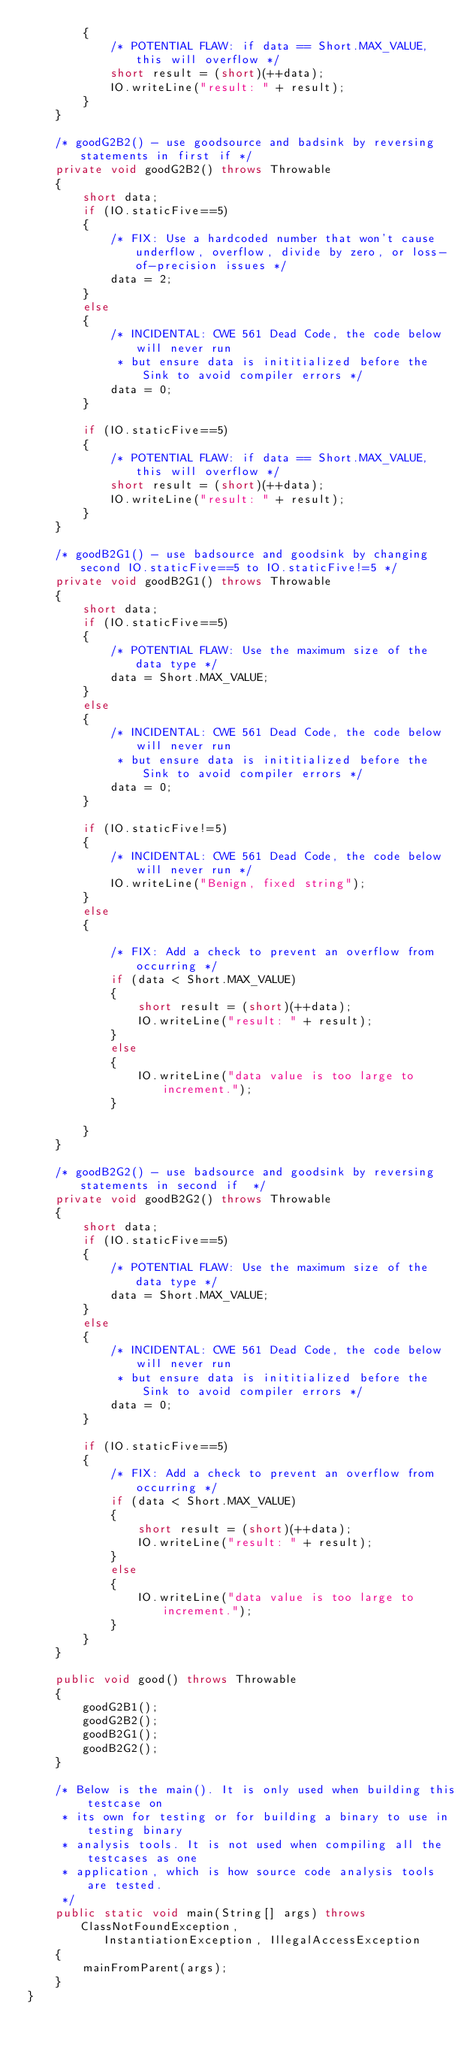<code> <loc_0><loc_0><loc_500><loc_500><_Java_>        {
            /* POTENTIAL FLAW: if data == Short.MAX_VALUE, this will overflow */
            short result = (short)(++data);
            IO.writeLine("result: " + result);
        }
    }

    /* goodG2B2() - use goodsource and badsink by reversing statements in first if */
    private void goodG2B2() throws Throwable
    {
        short data;
        if (IO.staticFive==5)
        {
            /* FIX: Use a hardcoded number that won't cause underflow, overflow, divide by zero, or loss-of-precision issues */
            data = 2;
        }
        else
        {
            /* INCIDENTAL: CWE 561 Dead Code, the code below will never run
             * but ensure data is inititialized before the Sink to avoid compiler errors */
            data = 0;
        }

        if (IO.staticFive==5)
        {
            /* POTENTIAL FLAW: if data == Short.MAX_VALUE, this will overflow */
            short result = (short)(++data);
            IO.writeLine("result: " + result);
        }
    }

    /* goodB2G1() - use badsource and goodsink by changing second IO.staticFive==5 to IO.staticFive!=5 */
    private void goodB2G1() throws Throwable
    {
        short data;
        if (IO.staticFive==5)
        {
            /* POTENTIAL FLAW: Use the maximum size of the data type */
            data = Short.MAX_VALUE;
        }
        else
        {
            /* INCIDENTAL: CWE 561 Dead Code, the code below will never run
             * but ensure data is inititialized before the Sink to avoid compiler errors */
            data = 0;
        }

        if (IO.staticFive!=5)
        {
            /* INCIDENTAL: CWE 561 Dead Code, the code below will never run */
            IO.writeLine("Benign, fixed string");
        }
        else
        {

            /* FIX: Add a check to prevent an overflow from occurring */
            if (data < Short.MAX_VALUE)
            {
                short result = (short)(++data);
                IO.writeLine("result: " + result);
            }
            else
            {
                IO.writeLine("data value is too large to increment.");
            }

        }
    }

    /* goodB2G2() - use badsource and goodsink by reversing statements in second if  */
    private void goodB2G2() throws Throwable
    {
        short data;
        if (IO.staticFive==5)
        {
            /* POTENTIAL FLAW: Use the maximum size of the data type */
            data = Short.MAX_VALUE;
        }
        else
        {
            /* INCIDENTAL: CWE 561 Dead Code, the code below will never run
             * but ensure data is inititialized before the Sink to avoid compiler errors */
            data = 0;
        }

        if (IO.staticFive==5)
        {
            /* FIX: Add a check to prevent an overflow from occurring */
            if (data < Short.MAX_VALUE)
            {
                short result = (short)(++data);
                IO.writeLine("result: " + result);
            }
            else
            {
                IO.writeLine("data value is too large to increment.");
            }
        }
    }

    public void good() throws Throwable
    {
        goodG2B1();
        goodG2B2();
        goodB2G1();
        goodB2G2();
    }

    /* Below is the main(). It is only used when building this testcase on
     * its own for testing or for building a binary to use in testing binary
     * analysis tools. It is not used when compiling all the testcases as one
     * application, which is how source code analysis tools are tested.
     */
    public static void main(String[] args) throws ClassNotFoundException,
           InstantiationException, IllegalAccessException
    {
        mainFromParent(args);
    }
}
</code> 